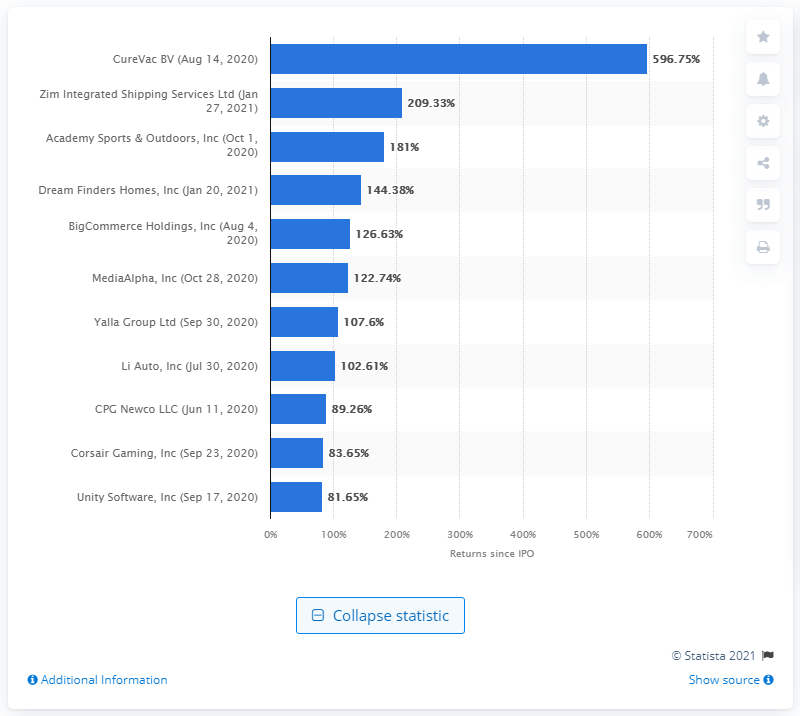Give some essential details in this illustration. CureVac's stock price increased by 596.75% between August 2020 and May 29, 2021. 